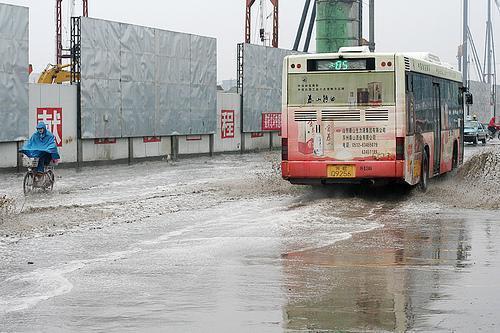Which object is in the greatest danger?
Indicate the correct response and explain using: 'Answer: answer
Rationale: rationale.'
Options: Bus, motorcyclist, blue car, cyclist. Answer: cyclist.
Rationale: The water is very deep for the bike. 